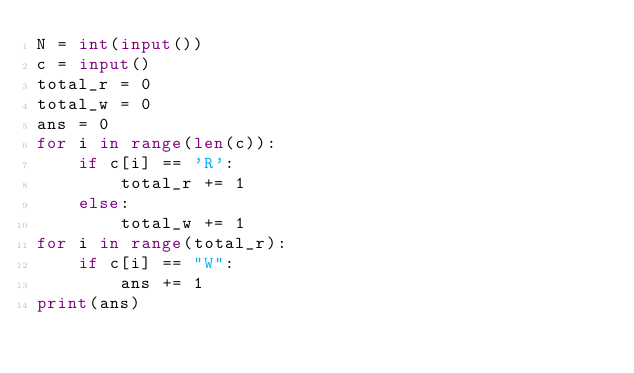<code> <loc_0><loc_0><loc_500><loc_500><_Python_>N = int(input())
c = input()
total_r = 0
total_w = 0
ans = 0
for i in range(len(c)):
    if c[i] == 'R':
        total_r += 1
    else:
        total_w += 1
for i in range(total_r):
    if c[i] == "W":
        ans += 1
print(ans)
    </code> 